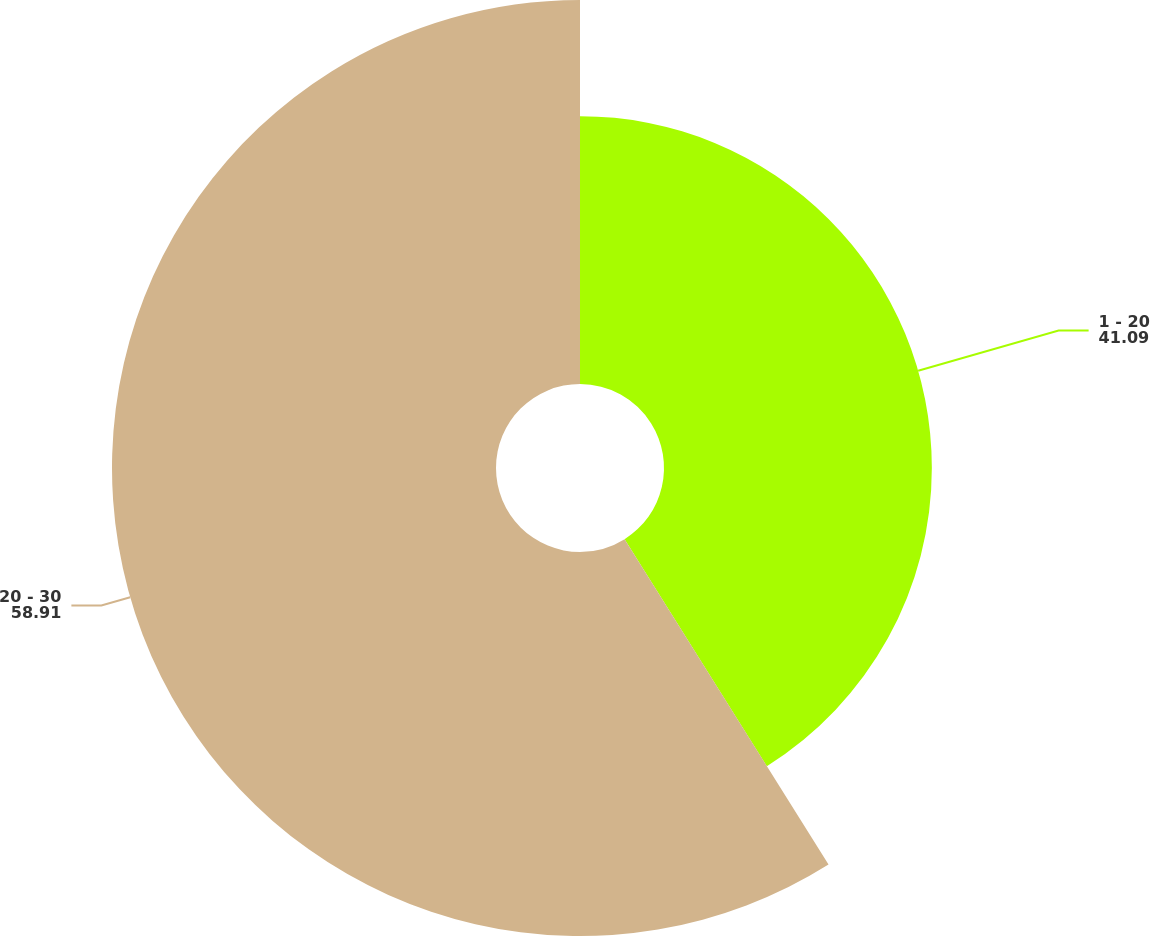<chart> <loc_0><loc_0><loc_500><loc_500><pie_chart><fcel>1 - 20<fcel>20 - 30<nl><fcel>41.09%<fcel>58.91%<nl></chart> 